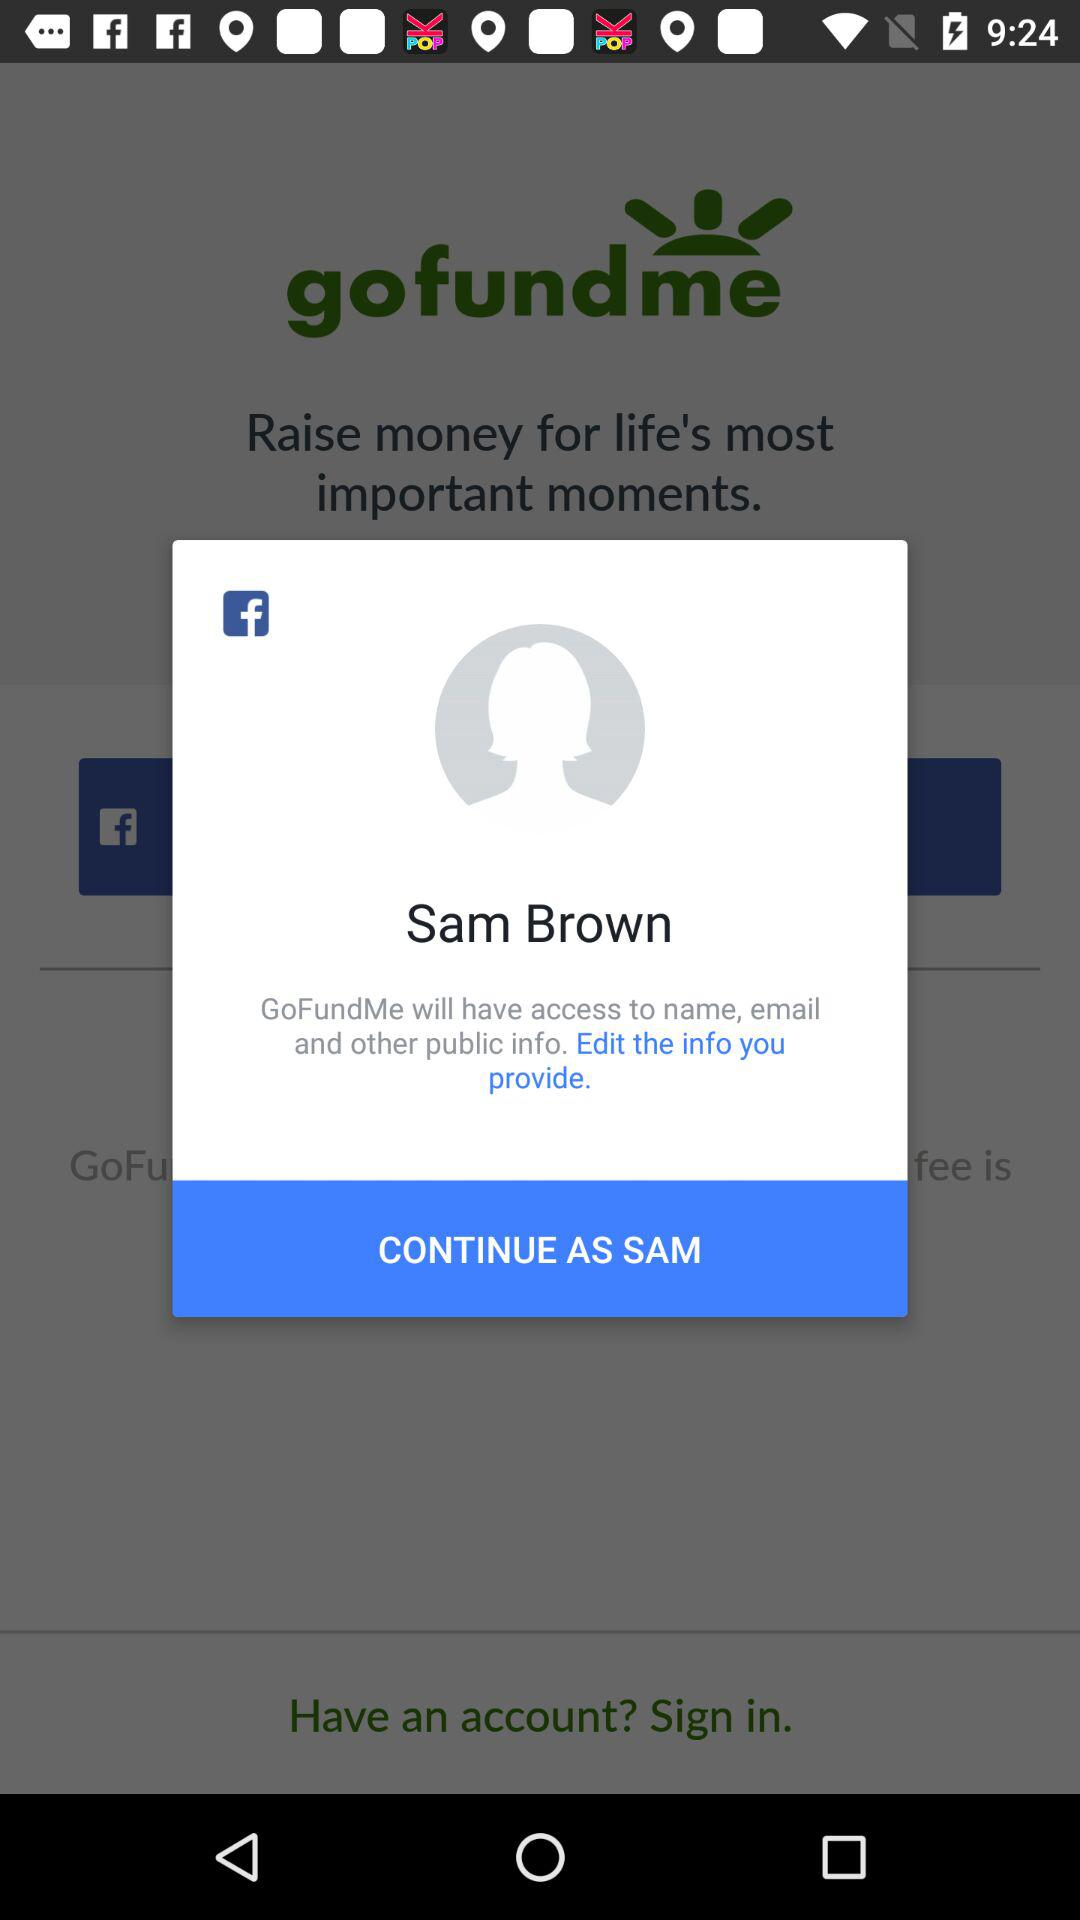What application will have access to names, email and other public information? The application "GoFundMe" will have access to names, email and other public information. 